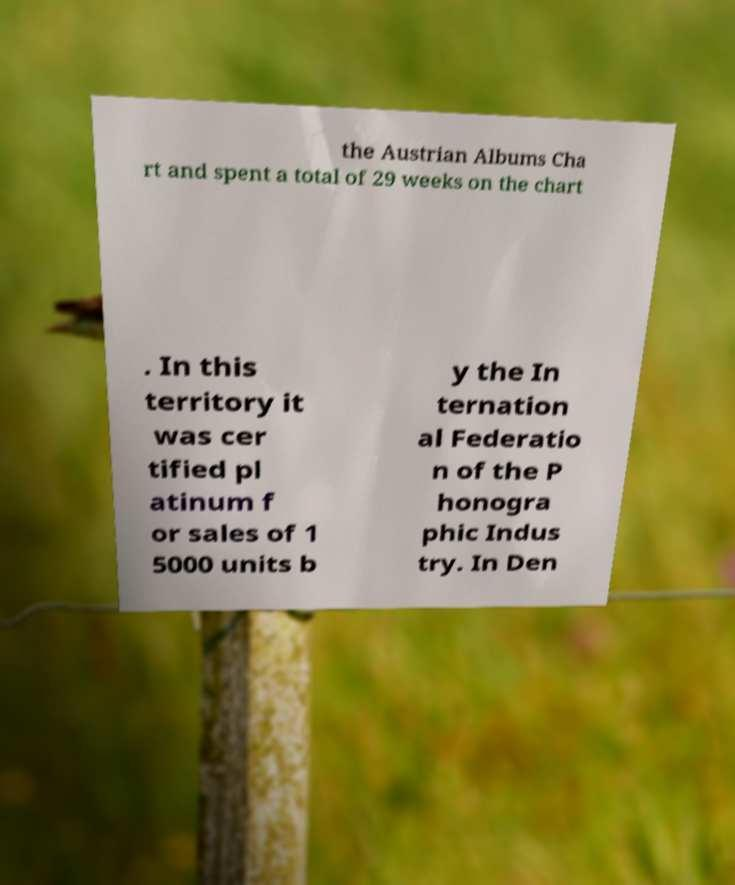There's text embedded in this image that I need extracted. Can you transcribe it verbatim? the Austrian Albums Cha rt and spent a total of 29 weeks on the chart . In this territory it was cer tified pl atinum f or sales of 1 5000 units b y the In ternation al Federatio n of the P honogra phic Indus try. In Den 